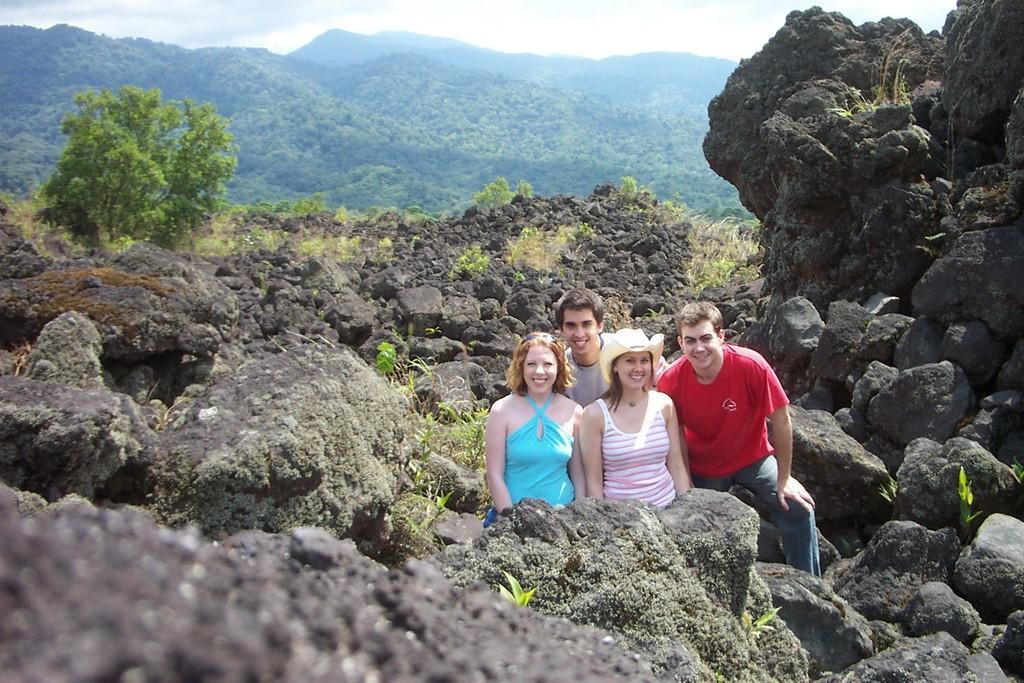In one or two sentences, can you explain what this image depicts? There are people smiling and this woman wore hat and we can see stones. In the background we can see trees and sky. 